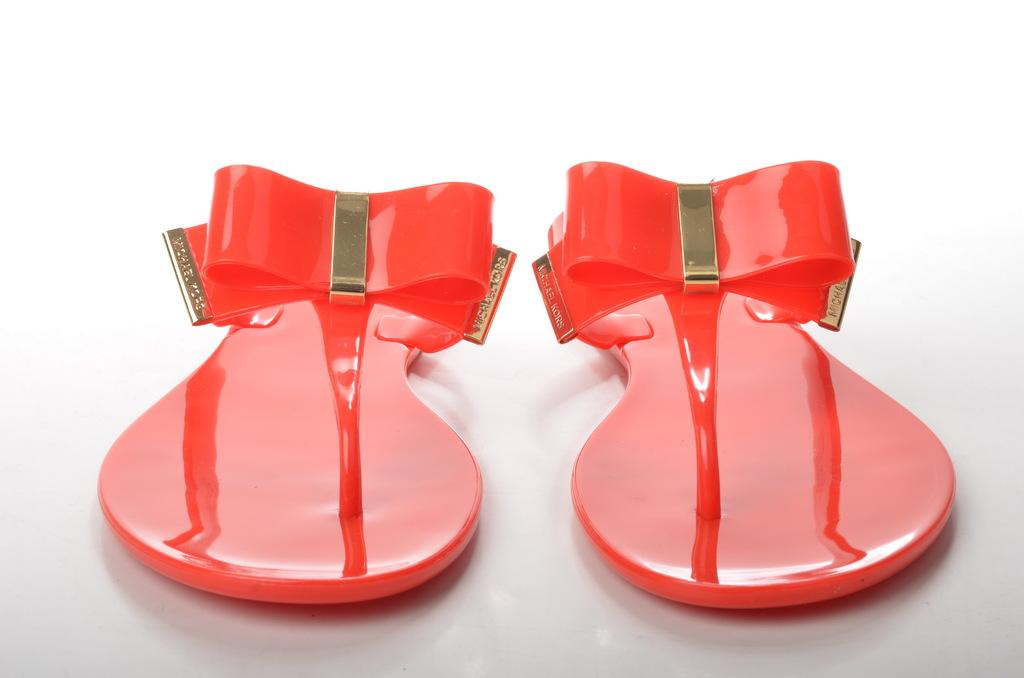What type of footwear is visible in the image? There is a pair of red color sandals in the image. What color is the object on which the sandals are placed? The object on which the sandals are placed is white. How does the root of the sandals provide pleasure in the image? There is no root present in the image, and therefore no such pleasure can be observed. 